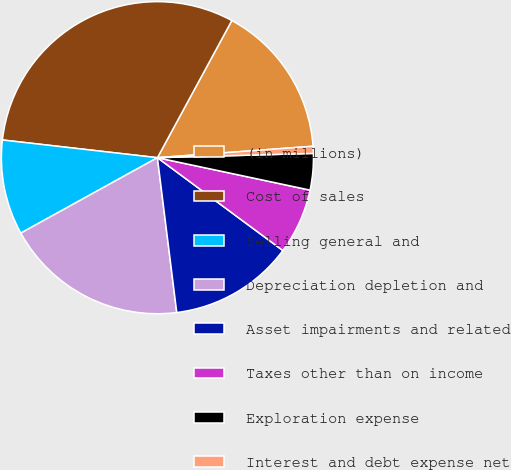<chart> <loc_0><loc_0><loc_500><loc_500><pie_chart><fcel>(in millions)<fcel>Cost of sales<fcel>Selling general and<fcel>Depreciation depletion and<fcel>Asset impairments and related<fcel>Taxes other than on income<fcel>Exploration expense<fcel>Interest and debt expense net<nl><fcel>15.92%<fcel>31.1%<fcel>9.84%<fcel>18.95%<fcel>12.88%<fcel>6.81%<fcel>3.77%<fcel>0.73%<nl></chart> 